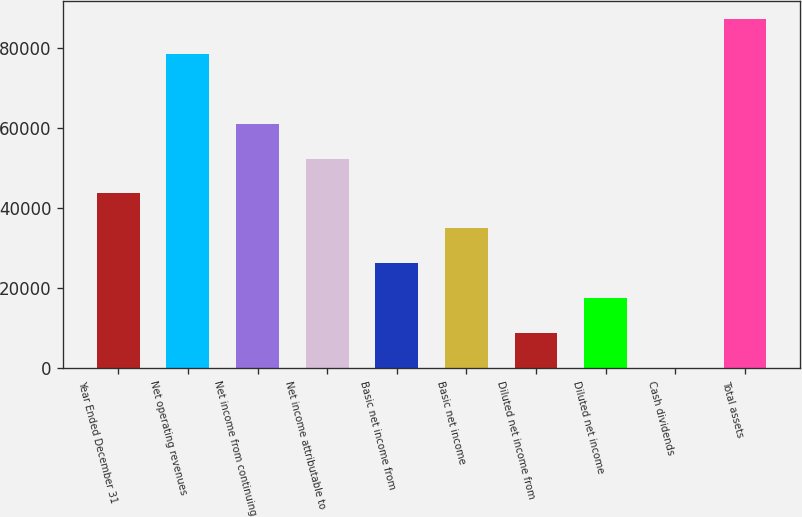<chart> <loc_0><loc_0><loc_500><loc_500><bar_chart><fcel>Year Ended December 31<fcel>Net operating revenues<fcel>Net income from continuing<fcel>Net income attributable to<fcel>Basic net income from<fcel>Basic net income<fcel>Diluted net income from<fcel>Diluted net income<fcel>Cash dividends<fcel>Total assets<nl><fcel>43635.7<fcel>78543.1<fcel>61089.4<fcel>52362.6<fcel>26182<fcel>34908.8<fcel>8728.26<fcel>17455.1<fcel>1.4<fcel>87270<nl></chart> 